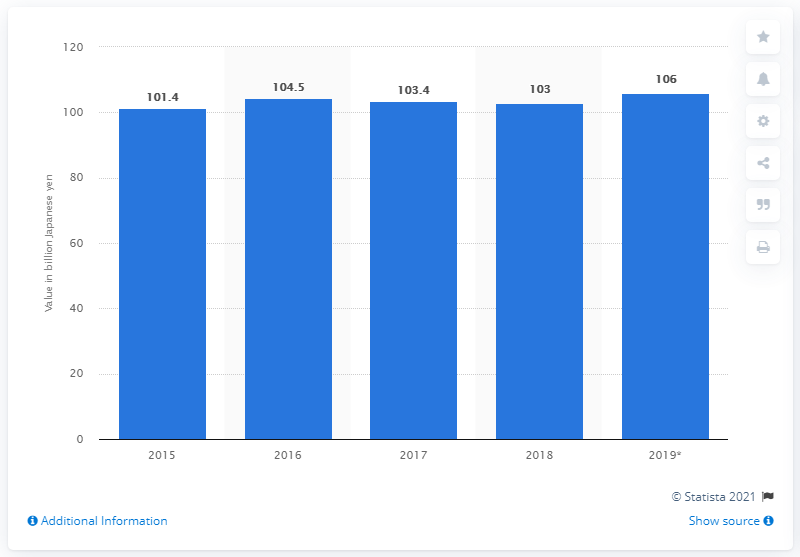Highlight a few significant elements in this photo. The non-contact self-pleasure market in Japan during the fiscal year 2015 was valued at approximately 101.4.. The non-contact self-pleasure market in Japan during fiscal year 2019 was valued at approximately 106... 